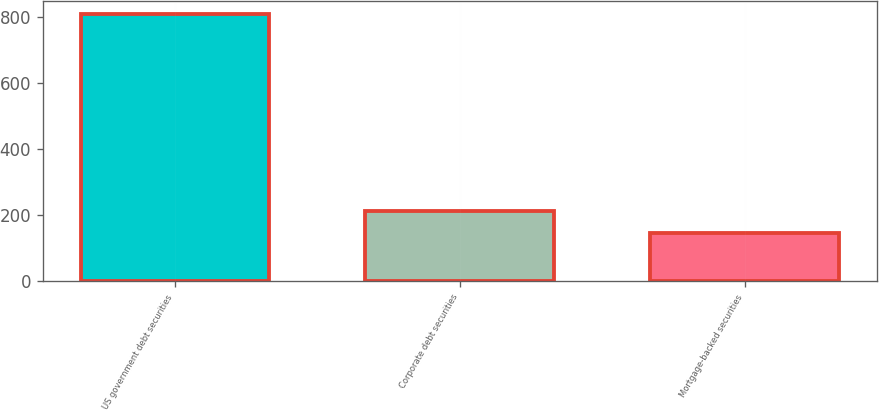<chart> <loc_0><loc_0><loc_500><loc_500><bar_chart><fcel>US government debt securities<fcel>Corporate debt securities<fcel>Mortgage-backed securities<nl><fcel>808<fcel>212.2<fcel>146<nl></chart> 